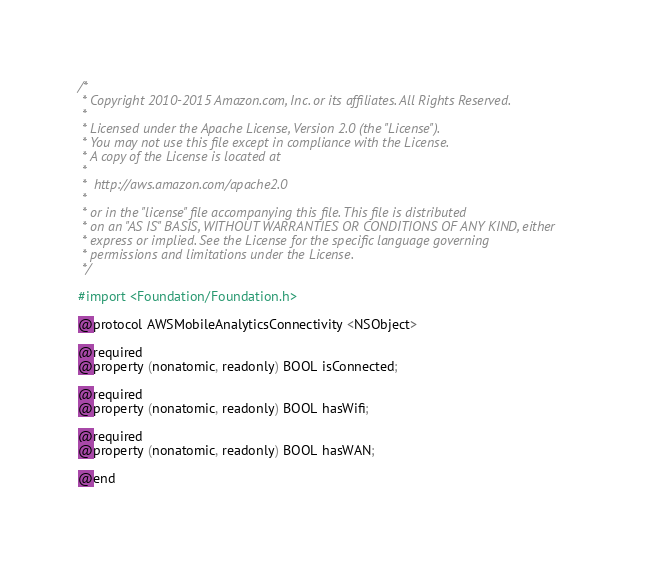Convert code to text. <code><loc_0><loc_0><loc_500><loc_500><_C_>/*
 * Copyright 2010-2015 Amazon.com, Inc. or its affiliates. All Rights Reserved.
 *
 * Licensed under the Apache License, Version 2.0 (the "License").
 * You may not use this file except in compliance with the License.
 * A copy of the License is located at
 *
 *  http://aws.amazon.com/apache2.0
 *
 * or in the "license" file accompanying this file. This file is distributed
 * on an "AS IS" BASIS, WITHOUT WARRANTIES OR CONDITIONS OF ANY KIND, either
 * express or implied. See the License for the specific language governing
 * permissions and limitations under the License.
 */

#import <Foundation/Foundation.h>

@protocol AWSMobileAnalyticsConnectivity <NSObject>

@required
@property (nonatomic, readonly) BOOL isConnected;

@required
@property (nonatomic, readonly) BOOL hasWifi;

@required
@property (nonatomic, readonly) BOOL hasWAN;

@end
</code> 